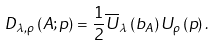Convert formula to latex. <formula><loc_0><loc_0><loc_500><loc_500>D _ { \lambda , \rho } \left ( A ; p \right ) = \frac { 1 } { 2 } \overline { U } _ { \lambda } \left ( b _ { A } \right ) U _ { \rho } \left ( p \right ) .</formula> 